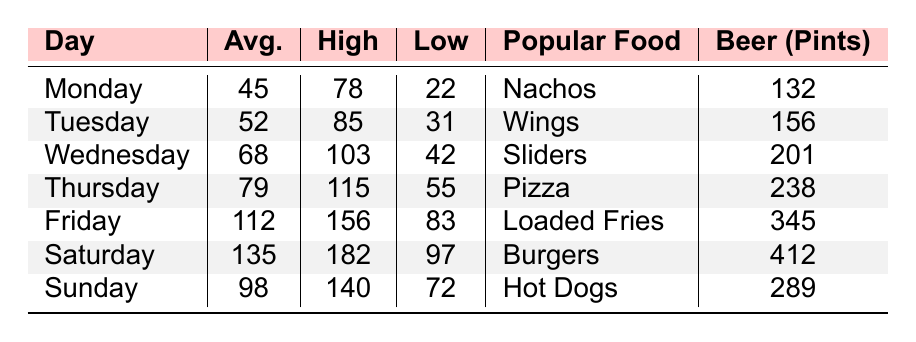What day had the highest average attendance? By looking at the "Average Attendance" column, Saturday has the highest value of 135 compared to the other days.
Answer: Saturday What was the highest attendance recorded on a Monday? Referring to the "Highest Attendance" column for Monday, the value is 78.
Answer: 78 Which day had the lowest beer sales in pints? From the "Beer Sales (Pints)" column, Monday has the lowest sales with a value of 132 pints.
Answer: 132 What is the sum of average attendance on Friday and Saturday? The average attendance for Friday is 112 and for Saturday is 135. Adding them gives 112 + 135 = 247.
Answer: 247 Which food item was the most popular on Thursdays? The "Most Popular Food Item" column shows that on Thursday, the most popular food item is Pizza.
Answer: Pizza Did the average attendance on Sundays exceed that of Mondays? The average attendance for Sunday is 98, while for Monday it is 45. Since 98 > 45, the statement is true.
Answer: Yes What was the difference in beer sales between the days with the highest and lowest attendance? Saturday has the highest attendance with 135 average attendees, and Monday has the lowest attendance at 45. Beer sales for Saturday is 412 pints and for Monday is 132 pints. The difference is 412 - 132 = 280.
Answer: 280 Which day had a higher average attendance, Friday or Wednesday? The average attendance for Friday is 112 and for Wednesday is 68. Since 112 > 68, Friday had a higher average attendance.
Answer: Friday What food item accompanied the highest average attendance day? Saturday, with the highest average attendance of 135, had Burgers as the most popular food item.
Answer: Burgers If Wednesday's attendance is doubled, what would be the new average attendance for that day? Wednesday's average attendance is 68. Doubling it gives 68 * 2 = 136.
Answer: 136 